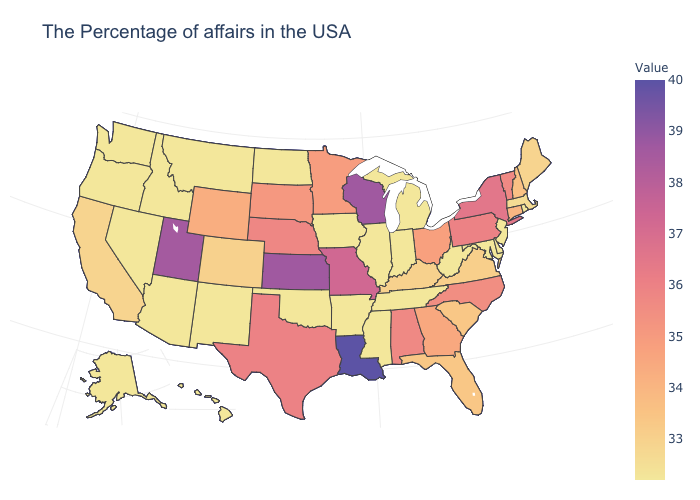Does North Carolina have the highest value in the South?
Give a very brief answer. No. Among the states that border Illinois , does Wisconsin have the lowest value?
Keep it brief. No. Does Minnesota have a higher value than Alaska?
Write a very short answer. Yes. Does Arkansas have the lowest value in the USA?
Write a very short answer. Yes. Among the states that border West Virginia , which have the highest value?
Concise answer only. Pennsylvania. Among the states that border Connecticut , does Rhode Island have the lowest value?
Answer briefly. Yes. Does Wyoming have a higher value than Missouri?
Concise answer only. No. 